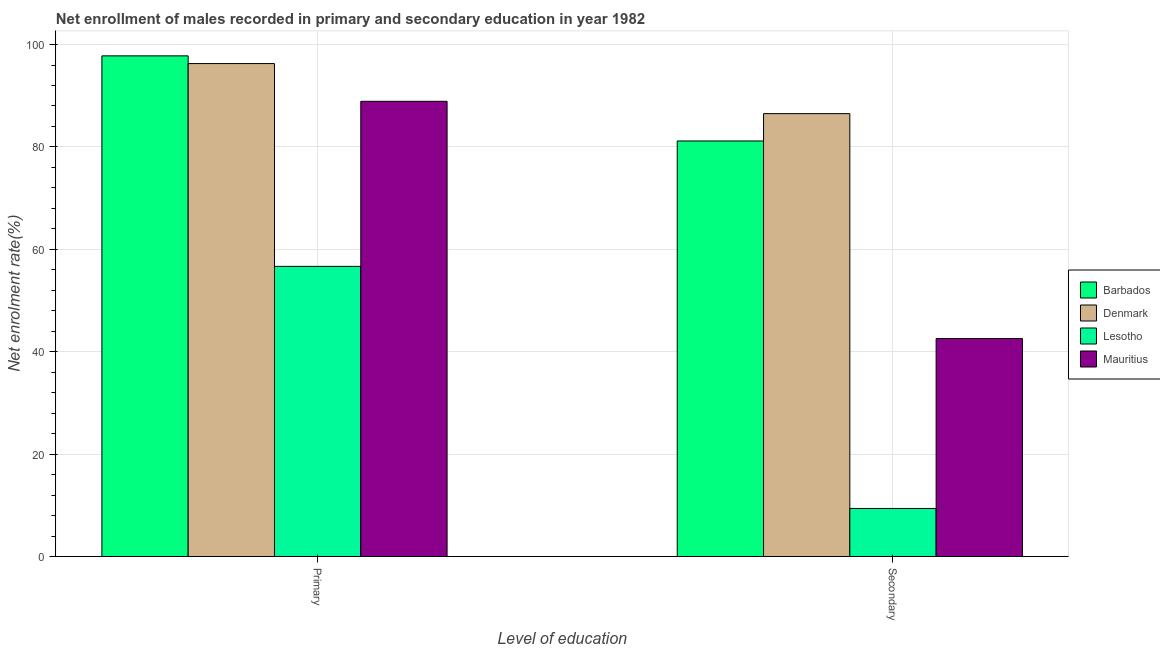How many groups of bars are there?
Keep it short and to the point. 2. Are the number of bars per tick equal to the number of legend labels?
Ensure brevity in your answer.  Yes. Are the number of bars on each tick of the X-axis equal?
Provide a succinct answer. Yes. How many bars are there on the 2nd tick from the left?
Provide a short and direct response. 4. What is the label of the 2nd group of bars from the left?
Your answer should be very brief. Secondary. What is the enrollment rate in secondary education in Lesotho?
Ensure brevity in your answer.  9.39. Across all countries, what is the maximum enrollment rate in primary education?
Your answer should be compact. 97.79. Across all countries, what is the minimum enrollment rate in primary education?
Offer a very short reply. 56.67. In which country was the enrollment rate in secondary education maximum?
Make the answer very short. Denmark. In which country was the enrollment rate in primary education minimum?
Give a very brief answer. Lesotho. What is the total enrollment rate in primary education in the graph?
Offer a very short reply. 339.65. What is the difference between the enrollment rate in secondary education in Denmark and that in Barbados?
Give a very brief answer. 5.34. What is the difference between the enrollment rate in secondary education in Mauritius and the enrollment rate in primary education in Barbados?
Offer a terse response. -55.21. What is the average enrollment rate in secondary education per country?
Your answer should be compact. 54.91. What is the difference between the enrollment rate in primary education and enrollment rate in secondary education in Barbados?
Your answer should be compact. 16.62. In how many countries, is the enrollment rate in secondary education greater than 96 %?
Keep it short and to the point. 0. What is the ratio of the enrollment rate in secondary education in Barbados to that in Denmark?
Offer a terse response. 0.94. In how many countries, is the enrollment rate in secondary education greater than the average enrollment rate in secondary education taken over all countries?
Provide a succinct answer. 2. What does the 1st bar from the right in Primary represents?
Offer a terse response. Mauritius. How many bars are there?
Make the answer very short. 8. What is the difference between two consecutive major ticks on the Y-axis?
Make the answer very short. 20. Where does the legend appear in the graph?
Your answer should be compact. Center right. How are the legend labels stacked?
Give a very brief answer. Vertical. What is the title of the graph?
Offer a very short reply. Net enrollment of males recorded in primary and secondary education in year 1982. What is the label or title of the X-axis?
Offer a terse response. Level of education. What is the label or title of the Y-axis?
Provide a short and direct response. Net enrolment rate(%). What is the Net enrolment rate(%) of Barbados in Primary?
Offer a terse response. 97.79. What is the Net enrolment rate(%) in Denmark in Primary?
Your answer should be very brief. 96.28. What is the Net enrolment rate(%) in Lesotho in Primary?
Ensure brevity in your answer.  56.67. What is the Net enrolment rate(%) in Mauritius in Primary?
Make the answer very short. 88.91. What is the Net enrolment rate(%) of Barbados in Secondary?
Ensure brevity in your answer.  81.17. What is the Net enrolment rate(%) of Denmark in Secondary?
Your answer should be compact. 86.5. What is the Net enrolment rate(%) of Lesotho in Secondary?
Your response must be concise. 9.39. What is the Net enrolment rate(%) of Mauritius in Secondary?
Offer a very short reply. 42.57. Across all Level of education, what is the maximum Net enrolment rate(%) in Barbados?
Make the answer very short. 97.79. Across all Level of education, what is the maximum Net enrolment rate(%) in Denmark?
Your answer should be very brief. 96.28. Across all Level of education, what is the maximum Net enrolment rate(%) of Lesotho?
Make the answer very short. 56.67. Across all Level of education, what is the maximum Net enrolment rate(%) in Mauritius?
Offer a terse response. 88.91. Across all Level of education, what is the minimum Net enrolment rate(%) in Barbados?
Offer a very short reply. 81.17. Across all Level of education, what is the minimum Net enrolment rate(%) in Denmark?
Provide a succinct answer. 86.5. Across all Level of education, what is the minimum Net enrolment rate(%) of Lesotho?
Provide a short and direct response. 9.39. Across all Level of education, what is the minimum Net enrolment rate(%) in Mauritius?
Give a very brief answer. 42.57. What is the total Net enrolment rate(%) of Barbados in the graph?
Keep it short and to the point. 178.95. What is the total Net enrolment rate(%) in Denmark in the graph?
Keep it short and to the point. 182.78. What is the total Net enrolment rate(%) of Lesotho in the graph?
Provide a short and direct response. 66.06. What is the total Net enrolment rate(%) in Mauritius in the graph?
Offer a very short reply. 131.49. What is the difference between the Net enrolment rate(%) of Barbados in Primary and that in Secondary?
Offer a very short reply. 16.62. What is the difference between the Net enrolment rate(%) in Denmark in Primary and that in Secondary?
Offer a very short reply. 9.78. What is the difference between the Net enrolment rate(%) in Lesotho in Primary and that in Secondary?
Make the answer very short. 47.29. What is the difference between the Net enrolment rate(%) of Mauritius in Primary and that in Secondary?
Offer a terse response. 46.34. What is the difference between the Net enrolment rate(%) of Barbados in Primary and the Net enrolment rate(%) of Denmark in Secondary?
Provide a succinct answer. 11.29. What is the difference between the Net enrolment rate(%) of Barbados in Primary and the Net enrolment rate(%) of Lesotho in Secondary?
Give a very brief answer. 88.4. What is the difference between the Net enrolment rate(%) in Barbados in Primary and the Net enrolment rate(%) in Mauritius in Secondary?
Your answer should be very brief. 55.21. What is the difference between the Net enrolment rate(%) of Denmark in Primary and the Net enrolment rate(%) of Lesotho in Secondary?
Provide a succinct answer. 86.9. What is the difference between the Net enrolment rate(%) in Denmark in Primary and the Net enrolment rate(%) in Mauritius in Secondary?
Ensure brevity in your answer.  53.71. What is the difference between the Net enrolment rate(%) of Lesotho in Primary and the Net enrolment rate(%) of Mauritius in Secondary?
Your answer should be very brief. 14.1. What is the average Net enrolment rate(%) of Barbados per Level of education?
Offer a very short reply. 89.48. What is the average Net enrolment rate(%) in Denmark per Level of education?
Make the answer very short. 91.39. What is the average Net enrolment rate(%) in Lesotho per Level of education?
Give a very brief answer. 33.03. What is the average Net enrolment rate(%) in Mauritius per Level of education?
Your response must be concise. 65.74. What is the difference between the Net enrolment rate(%) in Barbados and Net enrolment rate(%) in Denmark in Primary?
Provide a succinct answer. 1.51. What is the difference between the Net enrolment rate(%) of Barbados and Net enrolment rate(%) of Lesotho in Primary?
Give a very brief answer. 41.12. What is the difference between the Net enrolment rate(%) of Barbados and Net enrolment rate(%) of Mauritius in Primary?
Make the answer very short. 8.88. What is the difference between the Net enrolment rate(%) in Denmark and Net enrolment rate(%) in Lesotho in Primary?
Your response must be concise. 39.61. What is the difference between the Net enrolment rate(%) of Denmark and Net enrolment rate(%) of Mauritius in Primary?
Offer a very short reply. 7.37. What is the difference between the Net enrolment rate(%) in Lesotho and Net enrolment rate(%) in Mauritius in Primary?
Make the answer very short. -32.24. What is the difference between the Net enrolment rate(%) in Barbados and Net enrolment rate(%) in Denmark in Secondary?
Ensure brevity in your answer.  -5.34. What is the difference between the Net enrolment rate(%) in Barbados and Net enrolment rate(%) in Lesotho in Secondary?
Your answer should be compact. 71.78. What is the difference between the Net enrolment rate(%) in Barbados and Net enrolment rate(%) in Mauritius in Secondary?
Provide a short and direct response. 38.59. What is the difference between the Net enrolment rate(%) in Denmark and Net enrolment rate(%) in Lesotho in Secondary?
Provide a succinct answer. 77.11. What is the difference between the Net enrolment rate(%) of Denmark and Net enrolment rate(%) of Mauritius in Secondary?
Provide a short and direct response. 43.93. What is the difference between the Net enrolment rate(%) of Lesotho and Net enrolment rate(%) of Mauritius in Secondary?
Provide a short and direct response. -33.19. What is the ratio of the Net enrolment rate(%) in Barbados in Primary to that in Secondary?
Give a very brief answer. 1.2. What is the ratio of the Net enrolment rate(%) in Denmark in Primary to that in Secondary?
Give a very brief answer. 1.11. What is the ratio of the Net enrolment rate(%) of Lesotho in Primary to that in Secondary?
Make the answer very short. 6.04. What is the ratio of the Net enrolment rate(%) of Mauritius in Primary to that in Secondary?
Make the answer very short. 2.09. What is the difference between the highest and the second highest Net enrolment rate(%) of Barbados?
Your answer should be compact. 16.62. What is the difference between the highest and the second highest Net enrolment rate(%) in Denmark?
Ensure brevity in your answer.  9.78. What is the difference between the highest and the second highest Net enrolment rate(%) of Lesotho?
Keep it short and to the point. 47.29. What is the difference between the highest and the second highest Net enrolment rate(%) of Mauritius?
Give a very brief answer. 46.34. What is the difference between the highest and the lowest Net enrolment rate(%) of Barbados?
Make the answer very short. 16.62. What is the difference between the highest and the lowest Net enrolment rate(%) in Denmark?
Your answer should be compact. 9.78. What is the difference between the highest and the lowest Net enrolment rate(%) in Lesotho?
Offer a terse response. 47.29. What is the difference between the highest and the lowest Net enrolment rate(%) in Mauritius?
Your response must be concise. 46.34. 